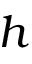<formula> <loc_0><loc_0><loc_500><loc_500>h</formula> 